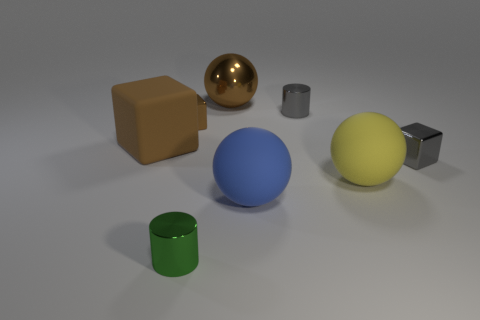Subtract all big rubber spheres. How many spheres are left? 1 Subtract all yellow balls. How many balls are left? 2 Add 1 small gray cubes. How many objects exist? 9 Add 8 blue things. How many blue things are left? 9 Add 1 large brown rubber things. How many large brown rubber things exist? 2 Subtract 0 purple cylinders. How many objects are left? 8 Subtract all cubes. How many objects are left? 5 Subtract 2 cubes. How many cubes are left? 1 Subtract all blue cylinders. Subtract all red cubes. How many cylinders are left? 2 Subtract all purple cylinders. How many purple cubes are left? 0 